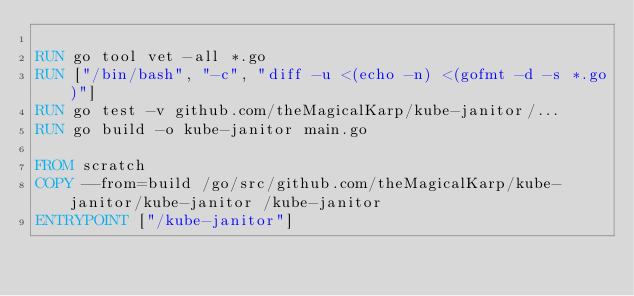<code> <loc_0><loc_0><loc_500><loc_500><_Dockerfile_>
RUN go tool vet -all *.go
RUN ["/bin/bash", "-c", "diff -u <(echo -n) <(gofmt -d -s *.go)"]
RUN go test -v github.com/theMagicalKarp/kube-janitor/...
RUN go build -o kube-janitor main.go

FROM scratch
COPY --from=build /go/src/github.com/theMagicalKarp/kube-janitor/kube-janitor /kube-janitor
ENTRYPOINT ["/kube-janitor"]
</code> 